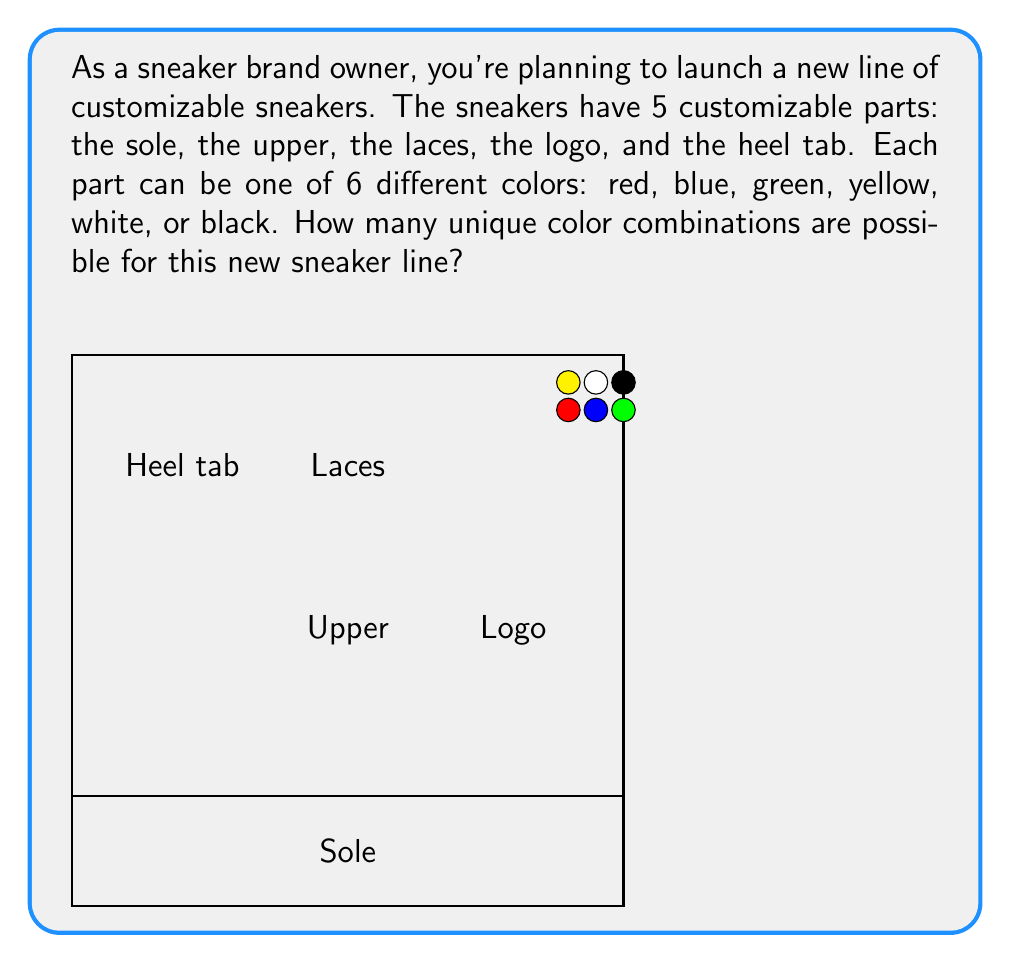Can you answer this question? To solve this problem, we can use the multiplication principle of combinatorics. Here's a step-by-step explanation:

1) We have 5 customizable parts of the sneaker:
   - Sole
   - Upper
   - Laces
   - Logo
   - Heel tab

2) Each part can be one of 6 colors:
   - Red
   - Blue
   - Green
   - Yellow
   - White
   - Black

3) For each part, we have 6 independent color choices. The choices for one part do not affect the choices for another part.

4) According to the multiplication principle, if we have a series of independent choices, the total number of possible outcomes is the product of the number of possibilities for each choice.

5) In this case, we have 5 independent choices (one for each part of the sneaker), and each choice has 6 possibilities (the 6 colors).

6) Therefore, the total number of unique color combinations is:

   $$ 6 \times 6 \times 6 \times 6 \times 6 = 6^5 $$

7) Calculate $6^5$:
   $$ 6^5 = 6 \times 6 \times 6 \times 6 \times 6 = 7,776 $$

Thus, there are 7,776 unique color combinations possible for the new sneaker line.
Answer: 7,776 